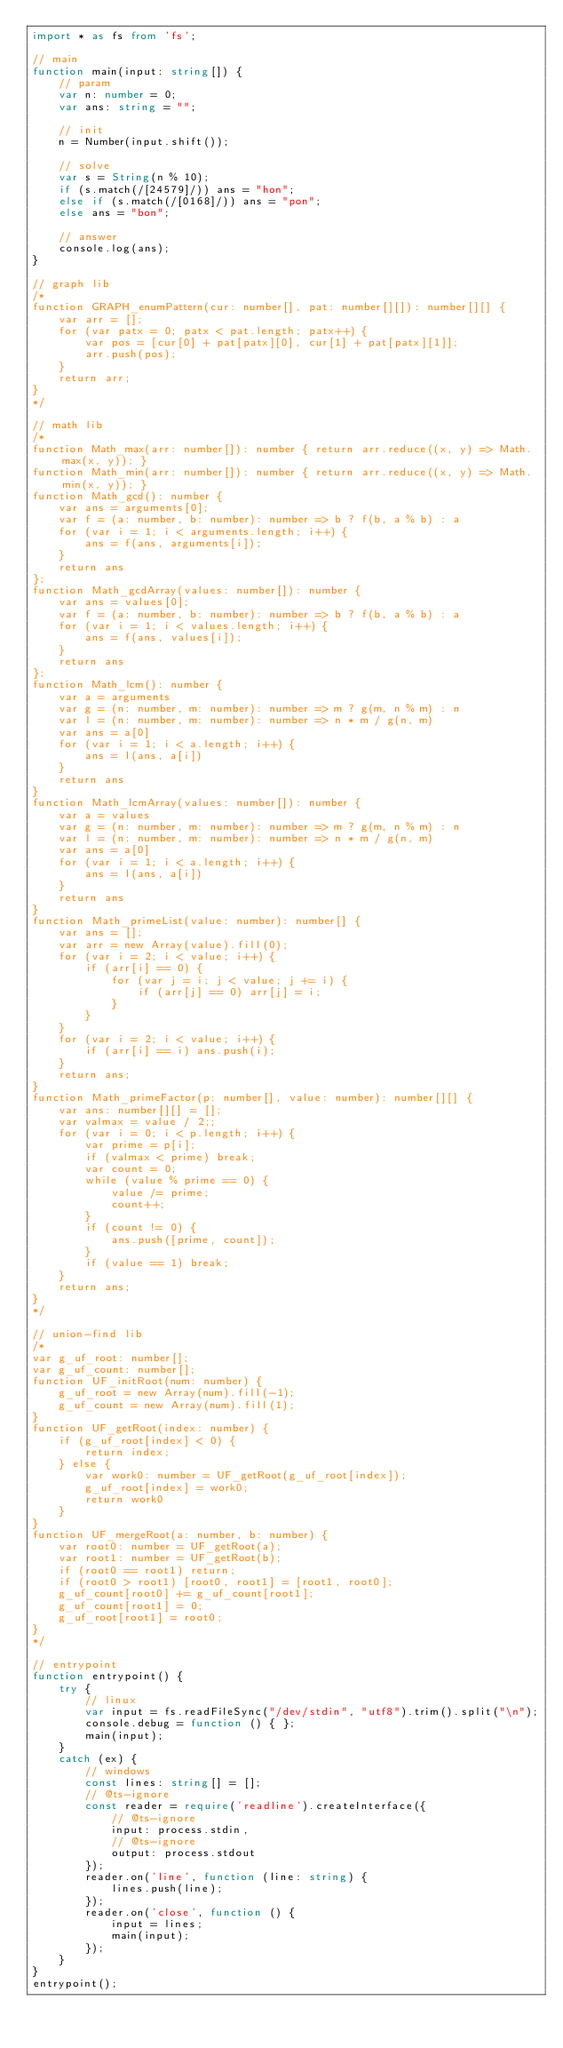<code> <loc_0><loc_0><loc_500><loc_500><_TypeScript_>import * as fs from 'fs';

// main
function main(input: string[]) {
    // param
    var n: number = 0;
    var ans: string = "";

    // init
    n = Number(input.shift());

    // solve
    var s = String(n % 10);
    if (s.match(/[24579]/)) ans = "hon";
    else if (s.match(/[0168]/)) ans = "pon";
    else ans = "bon";
    
    // answer
    console.log(ans);
}

// graph lib
/*
function GRAPH_enumPattern(cur: number[], pat: number[][]): number[][] {
    var arr = [];
    for (var patx = 0; patx < pat.length; patx++) {
        var pos = [cur[0] + pat[patx][0], cur[1] + pat[patx][1]];
        arr.push(pos);
    }
    return arr;
}
*/

// math lib
/*
function Math_max(arr: number[]): number { return arr.reduce((x, y) => Math.max(x, y)); }
function Math_min(arr: number[]): number { return arr.reduce((x, y) => Math.min(x, y)); }
function Math_gcd(): number {
    var ans = arguments[0];
    var f = (a: number, b: number): number => b ? f(b, a % b) : a
    for (var i = 1; i < arguments.length; i++) {
        ans = f(ans, arguments[i]);
    }
    return ans
};
function Math_gcdArray(values: number[]): number {
    var ans = values[0];
    var f = (a: number, b: number): number => b ? f(b, a % b) : a
    for (var i = 1; i < values.length; i++) {
        ans = f(ans, values[i]);
    }
    return ans
};
function Math_lcm(): number {
    var a = arguments
    var g = (n: number, m: number): number => m ? g(m, n % m) : n
    var l = (n: number, m: number): number => n * m / g(n, m)
    var ans = a[0]
    for (var i = 1; i < a.length; i++) {
        ans = l(ans, a[i])
    }
    return ans
}
function Math_lcmArray(values: number[]): number {
    var a = values
    var g = (n: number, m: number): number => m ? g(m, n % m) : n
    var l = (n: number, m: number): number => n * m / g(n, m)
    var ans = a[0]
    for (var i = 1; i < a.length; i++) {
        ans = l(ans, a[i])
    }
    return ans
}
function Math_primeList(value: number): number[] {
    var ans = [];
    var arr = new Array(value).fill(0);
    for (var i = 2; i < value; i++) {
        if (arr[i] == 0) {
            for (var j = i; j < value; j += i) {
                if (arr[j] == 0) arr[j] = i;
            }
        }
    }
    for (var i = 2; i < value; i++) {
        if (arr[i] == i) ans.push(i);
    }
    return ans;
}
function Math_primeFactor(p: number[], value: number): number[][] {
    var ans: number[][] = [];
    var valmax = value / 2;;
    for (var i = 0; i < p.length; i++) {
        var prime = p[i];
        if (valmax < prime) break;
        var count = 0;
        while (value % prime == 0) {
            value /= prime;
            count++;
        }
        if (count != 0) {
            ans.push([prime, count]);
        }
        if (value == 1) break;
    }
    return ans;
}
*/

// union-find lib
/*
var g_uf_root: number[];
var g_uf_count: number[];
function UF_initRoot(num: number) {
    g_uf_root = new Array(num).fill(-1);
    g_uf_count = new Array(num).fill(1);
}
function UF_getRoot(index: number) {
    if (g_uf_root[index] < 0) {
        return index;
    } else {
        var work0: number = UF_getRoot(g_uf_root[index]);
        g_uf_root[index] = work0;
        return work0
    }
}
function UF_mergeRoot(a: number, b: number) {
    var root0: number = UF_getRoot(a);
    var root1: number = UF_getRoot(b);
    if (root0 == root1) return;
    if (root0 > root1) [root0, root1] = [root1, root0];
    g_uf_count[root0] += g_uf_count[root1];
    g_uf_count[root1] = 0;
    g_uf_root[root1] = root0;
}
*/

// entrypoint
function entrypoint() {
    try {
        // linux
        var input = fs.readFileSync("/dev/stdin", "utf8").trim().split("\n");
        console.debug = function () { };
        main(input);
    }
    catch (ex) {
        // windows
        const lines: string[] = [];
        // @ts-ignore
        const reader = require('readline').createInterface({
            // @ts-ignore
            input: process.stdin,
            // @ts-ignore
            output: process.stdout
        });
        reader.on('line', function (line: string) {
            lines.push(line);
        });
        reader.on('close', function () {
            input = lines;
            main(input);
        });
    }
}
entrypoint();
</code> 